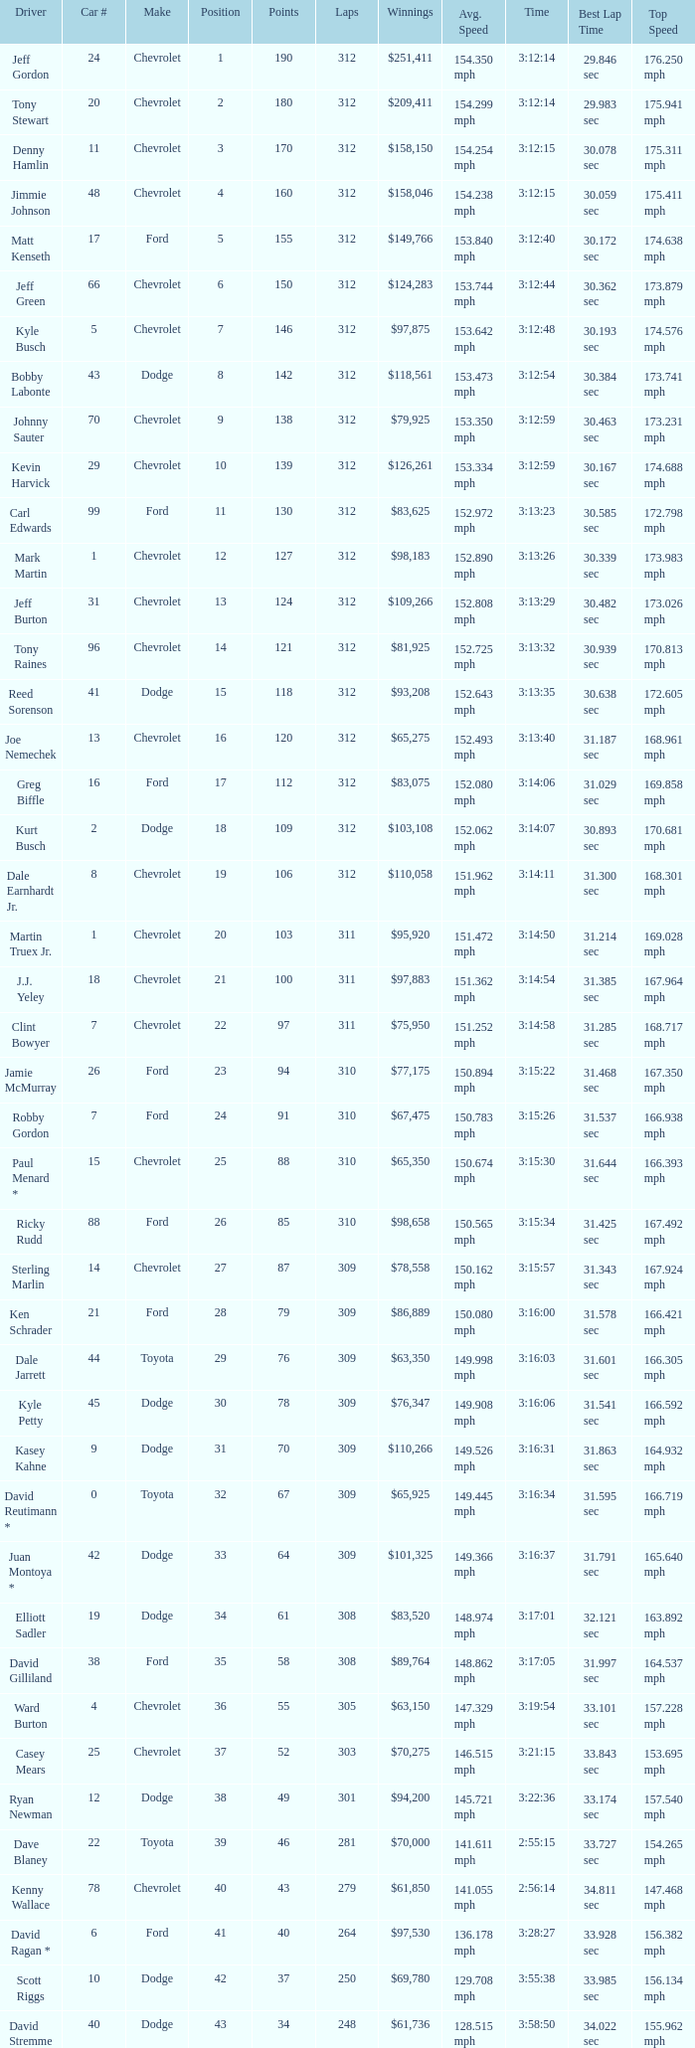What is the lowest number of laps for kyle petty with under 118 points? 309.0. 